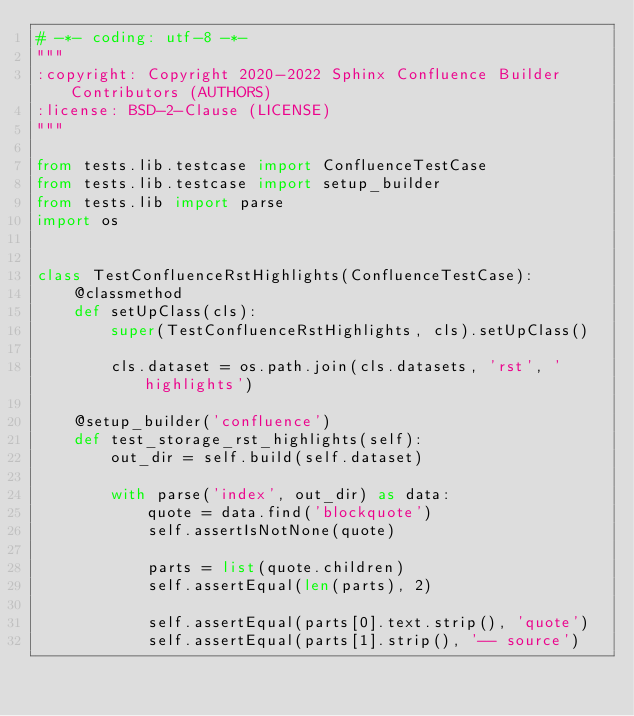<code> <loc_0><loc_0><loc_500><loc_500><_Python_># -*- coding: utf-8 -*-
"""
:copyright: Copyright 2020-2022 Sphinx Confluence Builder Contributors (AUTHORS)
:license: BSD-2-Clause (LICENSE)
"""

from tests.lib.testcase import ConfluenceTestCase
from tests.lib.testcase import setup_builder
from tests.lib import parse
import os


class TestConfluenceRstHighlights(ConfluenceTestCase):
    @classmethod
    def setUpClass(cls):
        super(TestConfluenceRstHighlights, cls).setUpClass()

        cls.dataset = os.path.join(cls.datasets, 'rst', 'highlights')

    @setup_builder('confluence')
    def test_storage_rst_highlights(self):
        out_dir = self.build(self.dataset)

        with parse('index', out_dir) as data:
            quote = data.find('blockquote')
            self.assertIsNotNone(quote)

            parts = list(quote.children)
            self.assertEqual(len(parts), 2)

            self.assertEqual(parts[0].text.strip(), 'quote')
            self.assertEqual(parts[1].strip(), '-- source')
</code> 